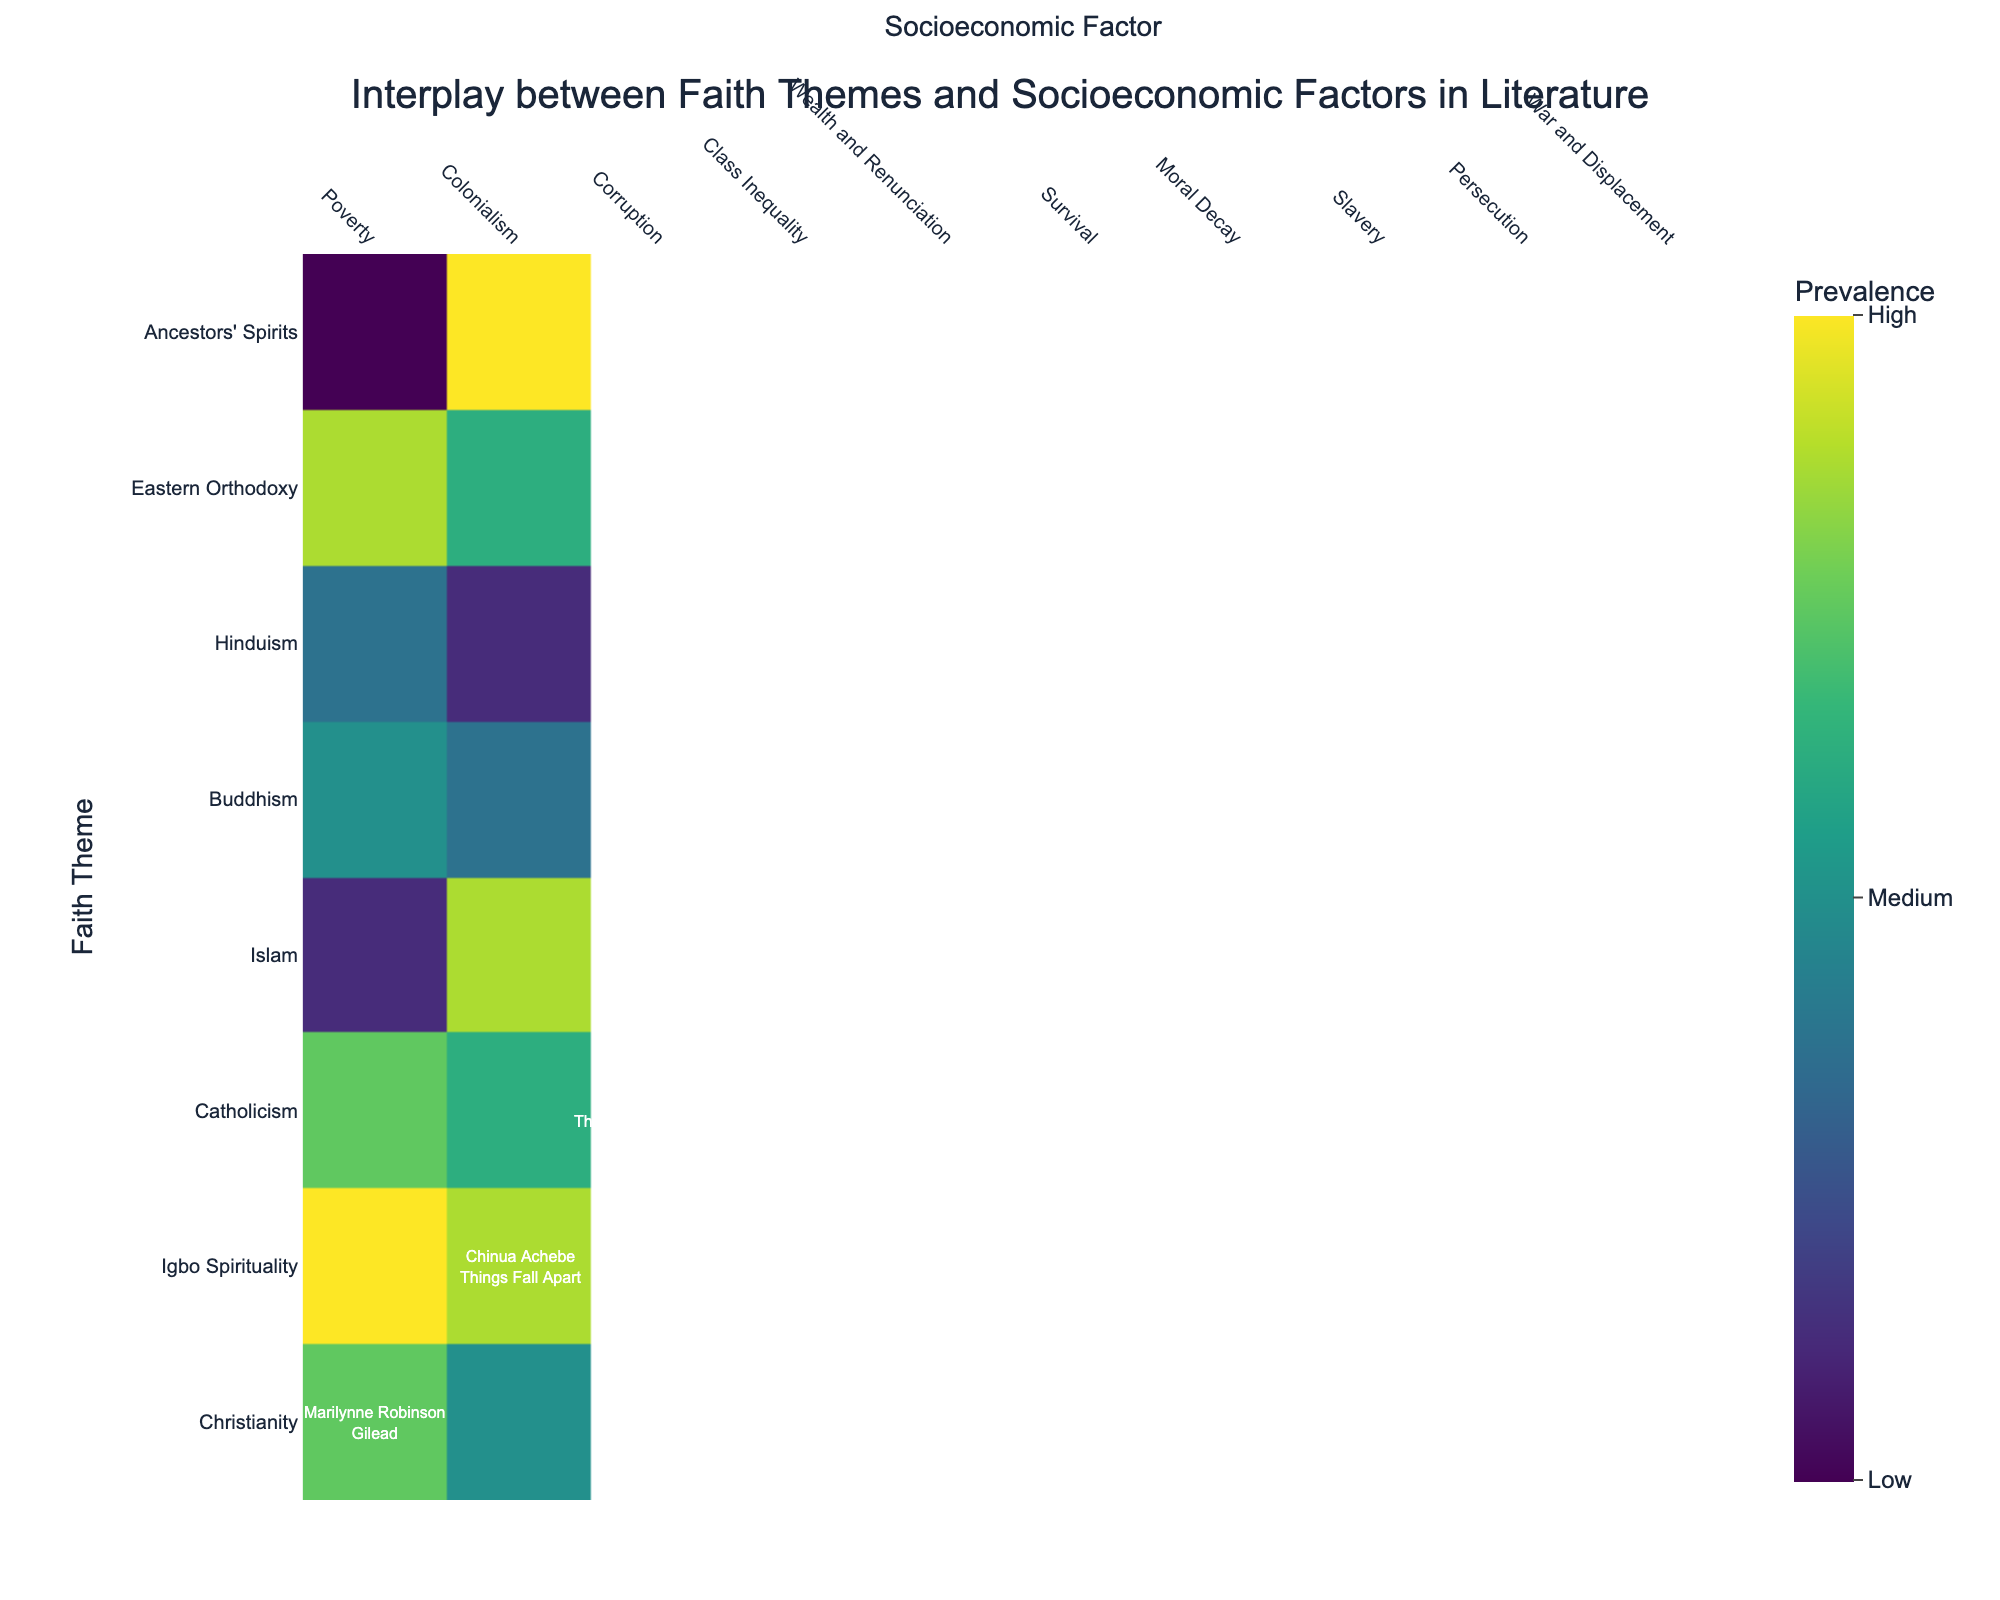What is the title of the figure? The title is prominently located at the top of the heatmap and written in a larger font. It reads "Interplay between Faith Themes and Socioeconomic Factors in Literature."
Answer: Interplay between Faith Themes and Socioeconomic Factors in Literature Which faith theme has the highest prevalence across all of its corresponding socioeconomic factors? The Igbo Spirituality faith theme associated with Colonialism has the highest prevalence, as indicated by a value of 90 on the heatmap.
Answer: Igbo Spirituality What socioeconomic factor is most commonly associated with Christian faith themes? To determine this, locate the faith themes related to Christianity and Catholicism, and then look at the socioeconomic factors associated with them. These are Poverty, Corruption, and Persecution. Each occurrence shows different prevalences, but the most frequent socioeconomic factor in these cases is Poverty.
Answer: Poverty Comparing 'The Kite Runner' and 'Burnt Shadows,' which novel portrays a higher prevalence of its faith theme in relation to its corresponding socioeconomic factor? 'The Kite Runner' has a prevalence of 60 for its faith theme, Islam, whereas 'Burnt Shadows' has a prevalence of 55 for its faith theme, Islam. By comparing these two values, 'The Kite Runner' portrays a higher prevalence of its faith theme.
Answer: The Kite Runner Which combination of faith theme and socioeconomic factor has both values falling in the 'High' range? The 'High' range values are 85 or higher. Igbo Spirituality and Colonialism have both prevalence values in this range, with 90 for the faith theme and 85 for the socioeconomic factor.
Answer: Igbo Spirituality and Colonialism Is 'Eastern Orthodoxy' more prevalent than 'Catholicism' in their respective socioeconomic contexts? Check the prevalence values for Eastern Orthodoxy and Catholicism in their contexts. Eastern Orthodoxy has a prevalence of 85, while Catholicism has prevalences of 75 and 80 in two separate novels. 85 is higher than both 75 and 80.
Answer: Yes Which author has the highest prevalence of the faith theme in their work and what is the value? The author associated with the highest prevalence of a faith theme is Chinua Achebe with Igbo Spirituality in 'Things Fall Apart.' The prevalence value is 90 for the faith theme.
Answer: Chinua Achebe, 90 What is the average prevalence of faith themes for all the novels listed? Add up all the prevalence values for the faith themes and divide by the number of entries. (80 + 90 + 75 + 60 + 70 + 65 + 85 + 50 + 80 + 55) / 10 = 71
Answer: 71 